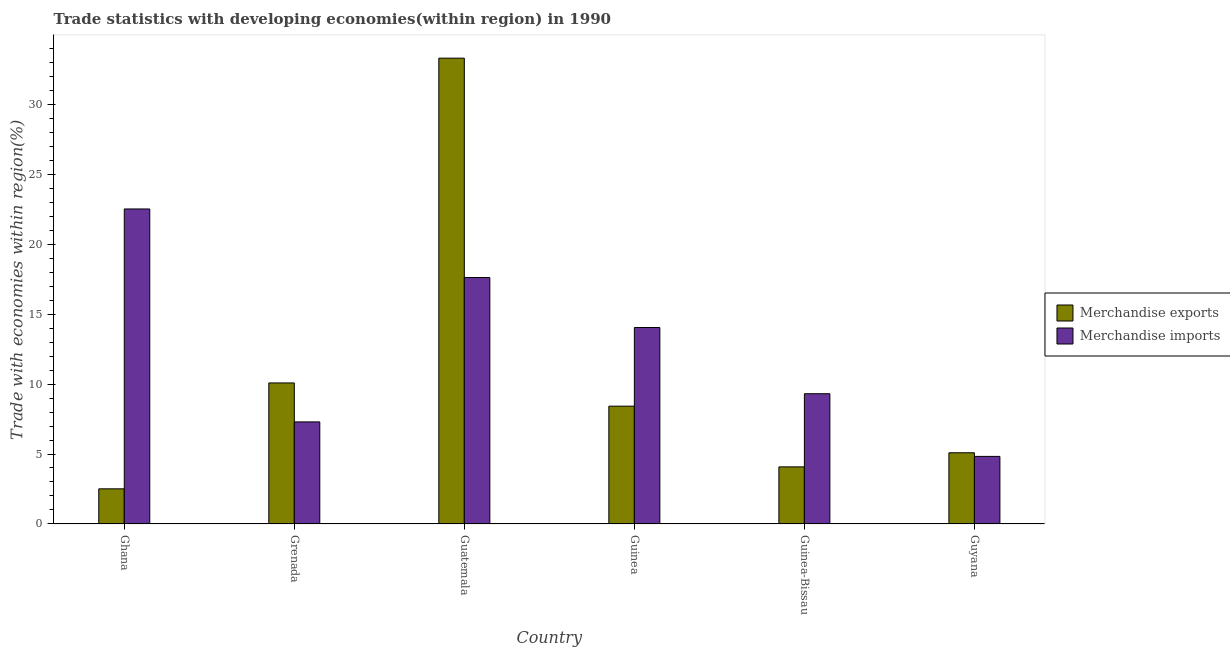How many different coloured bars are there?
Your answer should be compact. 2. How many groups of bars are there?
Ensure brevity in your answer.  6. Are the number of bars on each tick of the X-axis equal?
Offer a terse response. Yes. How many bars are there on the 4th tick from the right?
Provide a succinct answer. 2. In how many cases, is the number of bars for a given country not equal to the number of legend labels?
Your answer should be compact. 0. What is the merchandise exports in Guinea-Bissau?
Provide a short and direct response. 4.08. Across all countries, what is the maximum merchandise exports?
Offer a very short reply. 33.28. Across all countries, what is the minimum merchandise imports?
Provide a succinct answer. 4.83. In which country was the merchandise imports maximum?
Your response must be concise. Ghana. In which country was the merchandise exports minimum?
Your response must be concise. Ghana. What is the total merchandise exports in the graph?
Make the answer very short. 63.46. What is the difference between the merchandise imports in Guinea and that in Guinea-Bissau?
Give a very brief answer. 4.73. What is the difference between the merchandise imports in Ghana and the merchandise exports in Guinea-Bissau?
Provide a short and direct response. 18.43. What is the average merchandise imports per country?
Offer a terse response. 12.6. What is the difference between the merchandise exports and merchandise imports in Guatemala?
Your response must be concise. 15.67. In how many countries, is the merchandise imports greater than 18 %?
Make the answer very short. 1. What is the ratio of the merchandise imports in Ghana to that in Guinea-Bissau?
Ensure brevity in your answer.  2.42. Is the difference between the merchandise exports in Guatemala and Guinea greater than the difference between the merchandise imports in Guatemala and Guinea?
Make the answer very short. Yes. What is the difference between the highest and the second highest merchandise imports?
Offer a terse response. 4.9. What is the difference between the highest and the lowest merchandise exports?
Make the answer very short. 30.77. In how many countries, is the merchandise imports greater than the average merchandise imports taken over all countries?
Provide a short and direct response. 3. Is the sum of the merchandise exports in Ghana and Guinea-Bissau greater than the maximum merchandise imports across all countries?
Offer a terse response. No. What does the 2nd bar from the left in Guinea-Bissau represents?
Offer a terse response. Merchandise imports. How many bars are there?
Your answer should be very brief. 12. Where does the legend appear in the graph?
Your answer should be compact. Center right. How many legend labels are there?
Offer a terse response. 2. How are the legend labels stacked?
Make the answer very short. Vertical. What is the title of the graph?
Your answer should be very brief. Trade statistics with developing economies(within region) in 1990. What is the label or title of the X-axis?
Provide a succinct answer. Country. What is the label or title of the Y-axis?
Keep it short and to the point. Trade with economies within region(%). What is the Trade with economies within region(%) in Merchandise exports in Ghana?
Offer a very short reply. 2.51. What is the Trade with economies within region(%) in Merchandise imports in Ghana?
Your response must be concise. 22.51. What is the Trade with economies within region(%) of Merchandise exports in Grenada?
Offer a very short reply. 10.08. What is the Trade with economies within region(%) of Merchandise imports in Grenada?
Provide a succinct answer. 7.29. What is the Trade with economies within region(%) in Merchandise exports in Guatemala?
Make the answer very short. 33.28. What is the Trade with economies within region(%) of Merchandise imports in Guatemala?
Keep it short and to the point. 17.61. What is the Trade with economies within region(%) in Merchandise exports in Guinea?
Your answer should be compact. 8.42. What is the Trade with economies within region(%) in Merchandise imports in Guinea?
Keep it short and to the point. 14.04. What is the Trade with economies within region(%) in Merchandise exports in Guinea-Bissau?
Provide a short and direct response. 4.08. What is the Trade with economies within region(%) of Merchandise imports in Guinea-Bissau?
Ensure brevity in your answer.  9.31. What is the Trade with economies within region(%) in Merchandise exports in Guyana?
Offer a terse response. 5.09. What is the Trade with economies within region(%) of Merchandise imports in Guyana?
Give a very brief answer. 4.83. Across all countries, what is the maximum Trade with economies within region(%) of Merchandise exports?
Make the answer very short. 33.28. Across all countries, what is the maximum Trade with economies within region(%) of Merchandise imports?
Ensure brevity in your answer.  22.51. Across all countries, what is the minimum Trade with economies within region(%) of Merchandise exports?
Offer a very short reply. 2.51. Across all countries, what is the minimum Trade with economies within region(%) of Merchandise imports?
Provide a short and direct response. 4.83. What is the total Trade with economies within region(%) of Merchandise exports in the graph?
Make the answer very short. 63.46. What is the total Trade with economies within region(%) in Merchandise imports in the graph?
Provide a short and direct response. 75.59. What is the difference between the Trade with economies within region(%) in Merchandise exports in Ghana and that in Grenada?
Provide a short and direct response. -7.57. What is the difference between the Trade with economies within region(%) of Merchandise imports in Ghana and that in Grenada?
Keep it short and to the point. 15.21. What is the difference between the Trade with economies within region(%) of Merchandise exports in Ghana and that in Guatemala?
Ensure brevity in your answer.  -30.77. What is the difference between the Trade with economies within region(%) of Merchandise imports in Ghana and that in Guatemala?
Your answer should be compact. 4.9. What is the difference between the Trade with economies within region(%) in Merchandise exports in Ghana and that in Guinea?
Provide a short and direct response. -5.91. What is the difference between the Trade with economies within region(%) of Merchandise imports in Ghana and that in Guinea?
Offer a very short reply. 8.47. What is the difference between the Trade with economies within region(%) in Merchandise exports in Ghana and that in Guinea-Bissau?
Give a very brief answer. -1.57. What is the difference between the Trade with economies within region(%) in Merchandise imports in Ghana and that in Guinea-Bissau?
Provide a succinct answer. 13.2. What is the difference between the Trade with economies within region(%) in Merchandise exports in Ghana and that in Guyana?
Provide a succinct answer. -2.58. What is the difference between the Trade with economies within region(%) of Merchandise imports in Ghana and that in Guyana?
Your answer should be compact. 17.68. What is the difference between the Trade with economies within region(%) of Merchandise exports in Grenada and that in Guatemala?
Your answer should be very brief. -23.21. What is the difference between the Trade with economies within region(%) of Merchandise imports in Grenada and that in Guatemala?
Provide a short and direct response. -10.32. What is the difference between the Trade with economies within region(%) of Merchandise exports in Grenada and that in Guinea?
Your response must be concise. 1.66. What is the difference between the Trade with economies within region(%) in Merchandise imports in Grenada and that in Guinea?
Provide a succinct answer. -6.74. What is the difference between the Trade with economies within region(%) in Merchandise exports in Grenada and that in Guinea-Bissau?
Offer a terse response. 6. What is the difference between the Trade with economies within region(%) of Merchandise imports in Grenada and that in Guinea-Bissau?
Your response must be concise. -2.01. What is the difference between the Trade with economies within region(%) in Merchandise exports in Grenada and that in Guyana?
Give a very brief answer. 4.99. What is the difference between the Trade with economies within region(%) in Merchandise imports in Grenada and that in Guyana?
Ensure brevity in your answer.  2.47. What is the difference between the Trade with economies within region(%) of Merchandise exports in Guatemala and that in Guinea?
Provide a succinct answer. 24.87. What is the difference between the Trade with economies within region(%) in Merchandise imports in Guatemala and that in Guinea?
Offer a very short reply. 3.57. What is the difference between the Trade with economies within region(%) in Merchandise exports in Guatemala and that in Guinea-Bissau?
Provide a succinct answer. 29.21. What is the difference between the Trade with economies within region(%) of Merchandise imports in Guatemala and that in Guinea-Bissau?
Your response must be concise. 8.3. What is the difference between the Trade with economies within region(%) in Merchandise exports in Guatemala and that in Guyana?
Provide a succinct answer. 28.2. What is the difference between the Trade with economies within region(%) of Merchandise imports in Guatemala and that in Guyana?
Provide a succinct answer. 12.78. What is the difference between the Trade with economies within region(%) of Merchandise exports in Guinea and that in Guinea-Bissau?
Give a very brief answer. 4.34. What is the difference between the Trade with economies within region(%) of Merchandise imports in Guinea and that in Guinea-Bissau?
Offer a very short reply. 4.73. What is the difference between the Trade with economies within region(%) in Merchandise exports in Guinea and that in Guyana?
Your answer should be very brief. 3.33. What is the difference between the Trade with economies within region(%) of Merchandise imports in Guinea and that in Guyana?
Offer a very short reply. 9.21. What is the difference between the Trade with economies within region(%) in Merchandise exports in Guinea-Bissau and that in Guyana?
Your answer should be very brief. -1.01. What is the difference between the Trade with economies within region(%) of Merchandise imports in Guinea-Bissau and that in Guyana?
Provide a short and direct response. 4.48. What is the difference between the Trade with economies within region(%) in Merchandise exports in Ghana and the Trade with economies within region(%) in Merchandise imports in Grenada?
Give a very brief answer. -4.78. What is the difference between the Trade with economies within region(%) in Merchandise exports in Ghana and the Trade with economies within region(%) in Merchandise imports in Guatemala?
Offer a very short reply. -15.1. What is the difference between the Trade with economies within region(%) in Merchandise exports in Ghana and the Trade with economies within region(%) in Merchandise imports in Guinea?
Your response must be concise. -11.53. What is the difference between the Trade with economies within region(%) of Merchandise exports in Ghana and the Trade with economies within region(%) of Merchandise imports in Guinea-Bissau?
Your answer should be compact. -6.8. What is the difference between the Trade with economies within region(%) in Merchandise exports in Ghana and the Trade with economies within region(%) in Merchandise imports in Guyana?
Your answer should be very brief. -2.32. What is the difference between the Trade with economies within region(%) in Merchandise exports in Grenada and the Trade with economies within region(%) in Merchandise imports in Guatemala?
Your answer should be very brief. -7.53. What is the difference between the Trade with economies within region(%) in Merchandise exports in Grenada and the Trade with economies within region(%) in Merchandise imports in Guinea?
Ensure brevity in your answer.  -3.96. What is the difference between the Trade with economies within region(%) of Merchandise exports in Grenada and the Trade with economies within region(%) of Merchandise imports in Guinea-Bissau?
Make the answer very short. 0.77. What is the difference between the Trade with economies within region(%) in Merchandise exports in Grenada and the Trade with economies within region(%) in Merchandise imports in Guyana?
Offer a very short reply. 5.25. What is the difference between the Trade with economies within region(%) in Merchandise exports in Guatemala and the Trade with economies within region(%) in Merchandise imports in Guinea?
Make the answer very short. 19.25. What is the difference between the Trade with economies within region(%) of Merchandise exports in Guatemala and the Trade with economies within region(%) of Merchandise imports in Guinea-Bissau?
Provide a succinct answer. 23.98. What is the difference between the Trade with economies within region(%) of Merchandise exports in Guatemala and the Trade with economies within region(%) of Merchandise imports in Guyana?
Make the answer very short. 28.46. What is the difference between the Trade with economies within region(%) in Merchandise exports in Guinea and the Trade with economies within region(%) in Merchandise imports in Guinea-Bissau?
Your answer should be very brief. -0.89. What is the difference between the Trade with economies within region(%) in Merchandise exports in Guinea and the Trade with economies within region(%) in Merchandise imports in Guyana?
Offer a very short reply. 3.59. What is the difference between the Trade with economies within region(%) of Merchandise exports in Guinea-Bissau and the Trade with economies within region(%) of Merchandise imports in Guyana?
Offer a very short reply. -0.75. What is the average Trade with economies within region(%) of Merchandise exports per country?
Offer a very short reply. 10.58. What is the average Trade with economies within region(%) of Merchandise imports per country?
Provide a short and direct response. 12.6. What is the difference between the Trade with economies within region(%) of Merchandise exports and Trade with economies within region(%) of Merchandise imports in Ghana?
Your response must be concise. -20. What is the difference between the Trade with economies within region(%) of Merchandise exports and Trade with economies within region(%) of Merchandise imports in Grenada?
Your answer should be very brief. 2.78. What is the difference between the Trade with economies within region(%) of Merchandise exports and Trade with economies within region(%) of Merchandise imports in Guatemala?
Make the answer very short. 15.67. What is the difference between the Trade with economies within region(%) in Merchandise exports and Trade with economies within region(%) in Merchandise imports in Guinea?
Keep it short and to the point. -5.62. What is the difference between the Trade with economies within region(%) in Merchandise exports and Trade with economies within region(%) in Merchandise imports in Guinea-Bissau?
Your answer should be very brief. -5.23. What is the difference between the Trade with economies within region(%) in Merchandise exports and Trade with economies within region(%) in Merchandise imports in Guyana?
Keep it short and to the point. 0.26. What is the ratio of the Trade with economies within region(%) in Merchandise exports in Ghana to that in Grenada?
Keep it short and to the point. 0.25. What is the ratio of the Trade with economies within region(%) in Merchandise imports in Ghana to that in Grenada?
Ensure brevity in your answer.  3.09. What is the ratio of the Trade with economies within region(%) in Merchandise exports in Ghana to that in Guatemala?
Provide a succinct answer. 0.08. What is the ratio of the Trade with economies within region(%) of Merchandise imports in Ghana to that in Guatemala?
Your response must be concise. 1.28. What is the ratio of the Trade with economies within region(%) of Merchandise exports in Ghana to that in Guinea?
Make the answer very short. 0.3. What is the ratio of the Trade with economies within region(%) in Merchandise imports in Ghana to that in Guinea?
Your answer should be compact. 1.6. What is the ratio of the Trade with economies within region(%) of Merchandise exports in Ghana to that in Guinea-Bissau?
Your answer should be very brief. 0.62. What is the ratio of the Trade with economies within region(%) of Merchandise imports in Ghana to that in Guinea-Bissau?
Your answer should be compact. 2.42. What is the ratio of the Trade with economies within region(%) of Merchandise exports in Ghana to that in Guyana?
Your response must be concise. 0.49. What is the ratio of the Trade with economies within region(%) in Merchandise imports in Ghana to that in Guyana?
Your answer should be compact. 4.66. What is the ratio of the Trade with economies within region(%) in Merchandise exports in Grenada to that in Guatemala?
Keep it short and to the point. 0.3. What is the ratio of the Trade with economies within region(%) in Merchandise imports in Grenada to that in Guatemala?
Ensure brevity in your answer.  0.41. What is the ratio of the Trade with economies within region(%) in Merchandise exports in Grenada to that in Guinea?
Your answer should be compact. 1.2. What is the ratio of the Trade with economies within region(%) of Merchandise imports in Grenada to that in Guinea?
Your answer should be compact. 0.52. What is the ratio of the Trade with economies within region(%) of Merchandise exports in Grenada to that in Guinea-Bissau?
Ensure brevity in your answer.  2.47. What is the ratio of the Trade with economies within region(%) of Merchandise imports in Grenada to that in Guinea-Bissau?
Your answer should be compact. 0.78. What is the ratio of the Trade with economies within region(%) of Merchandise exports in Grenada to that in Guyana?
Offer a very short reply. 1.98. What is the ratio of the Trade with economies within region(%) in Merchandise imports in Grenada to that in Guyana?
Ensure brevity in your answer.  1.51. What is the ratio of the Trade with economies within region(%) of Merchandise exports in Guatemala to that in Guinea?
Your answer should be very brief. 3.95. What is the ratio of the Trade with economies within region(%) of Merchandise imports in Guatemala to that in Guinea?
Keep it short and to the point. 1.25. What is the ratio of the Trade with economies within region(%) in Merchandise exports in Guatemala to that in Guinea-Bissau?
Keep it short and to the point. 8.16. What is the ratio of the Trade with economies within region(%) in Merchandise imports in Guatemala to that in Guinea-Bissau?
Your response must be concise. 1.89. What is the ratio of the Trade with economies within region(%) of Merchandise exports in Guatemala to that in Guyana?
Your answer should be compact. 6.54. What is the ratio of the Trade with economies within region(%) of Merchandise imports in Guatemala to that in Guyana?
Give a very brief answer. 3.65. What is the ratio of the Trade with economies within region(%) in Merchandise exports in Guinea to that in Guinea-Bissau?
Your answer should be very brief. 2.06. What is the ratio of the Trade with economies within region(%) in Merchandise imports in Guinea to that in Guinea-Bissau?
Keep it short and to the point. 1.51. What is the ratio of the Trade with economies within region(%) of Merchandise exports in Guinea to that in Guyana?
Keep it short and to the point. 1.65. What is the ratio of the Trade with economies within region(%) in Merchandise imports in Guinea to that in Guyana?
Your answer should be compact. 2.91. What is the ratio of the Trade with economies within region(%) of Merchandise exports in Guinea-Bissau to that in Guyana?
Make the answer very short. 0.8. What is the ratio of the Trade with economies within region(%) in Merchandise imports in Guinea-Bissau to that in Guyana?
Give a very brief answer. 1.93. What is the difference between the highest and the second highest Trade with economies within region(%) in Merchandise exports?
Your answer should be compact. 23.21. What is the difference between the highest and the second highest Trade with economies within region(%) in Merchandise imports?
Offer a terse response. 4.9. What is the difference between the highest and the lowest Trade with economies within region(%) of Merchandise exports?
Your answer should be very brief. 30.77. What is the difference between the highest and the lowest Trade with economies within region(%) in Merchandise imports?
Make the answer very short. 17.68. 